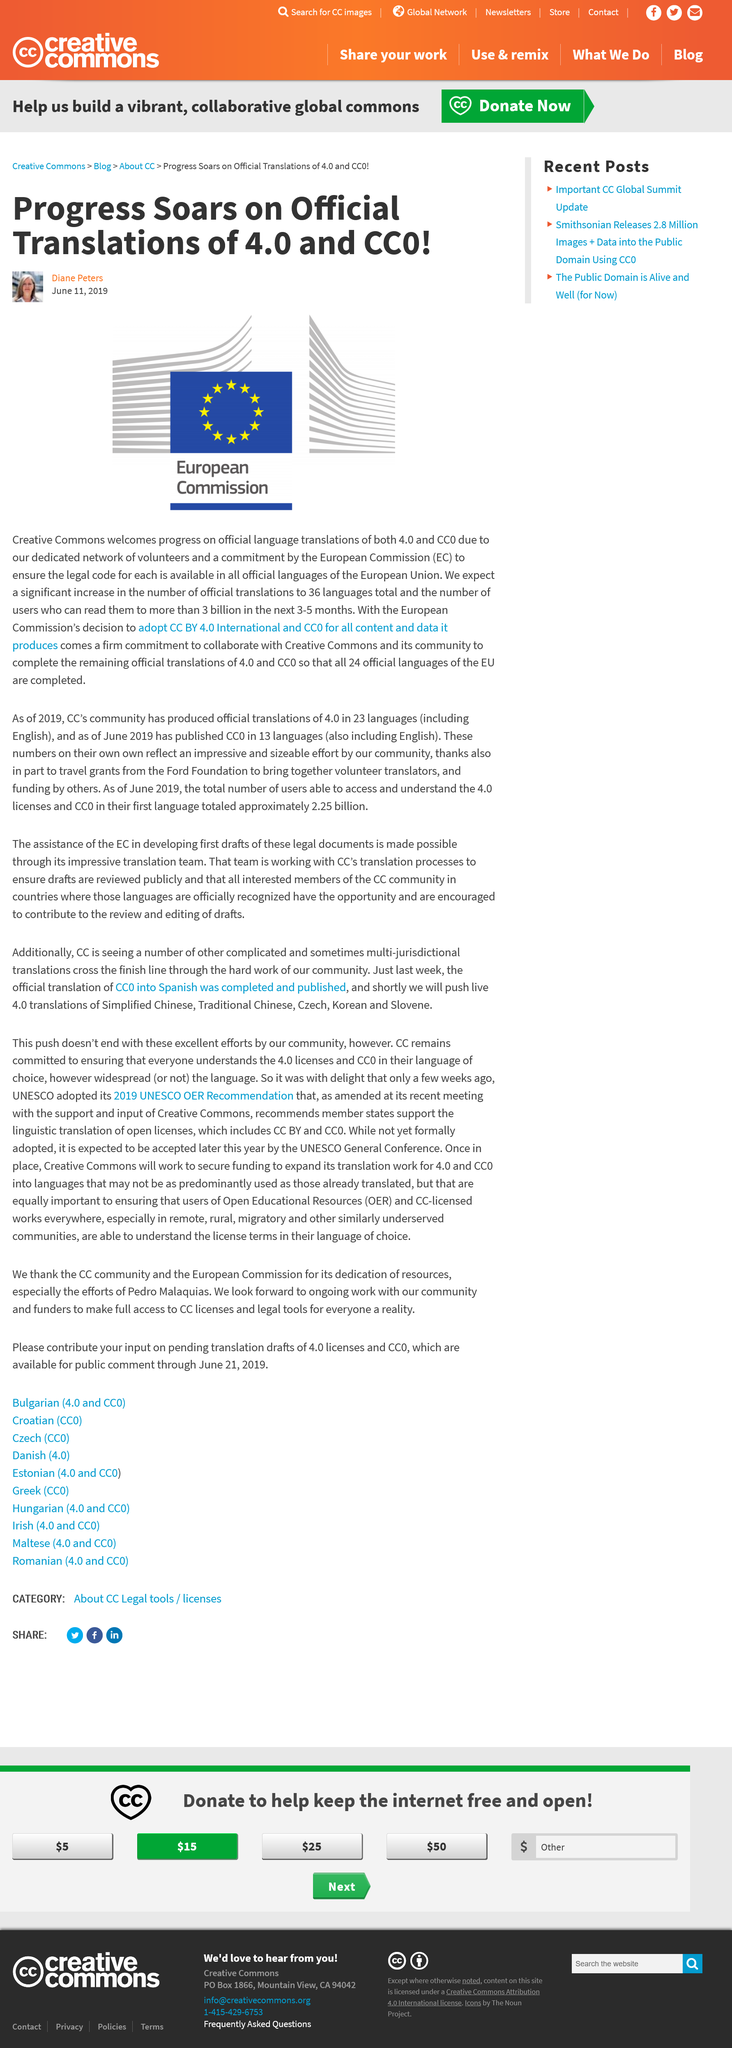Give some essential details in this illustration. The European Union has 24 official languages. The European Commission is committed to making the legal code available to all members of the EU. The European Union has 12 primary members. 